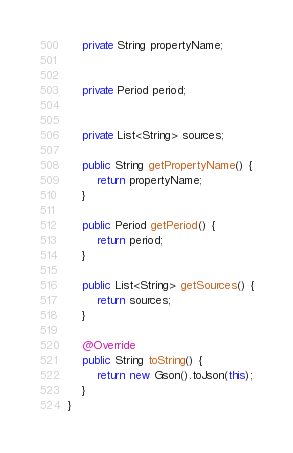<code> <loc_0><loc_0><loc_500><loc_500><_Java_>
    private String propertyName;


    private Period period;


    private List<String> sources;

    public String getPropertyName() {
        return propertyName;
    }

    public Period getPeriod() {
        return period;
    }

    public List<String> getSources() {
        return sources;
    }

    @Override
    public String toString() {
        return new Gson().toJson(this);
    }
}
</code> 